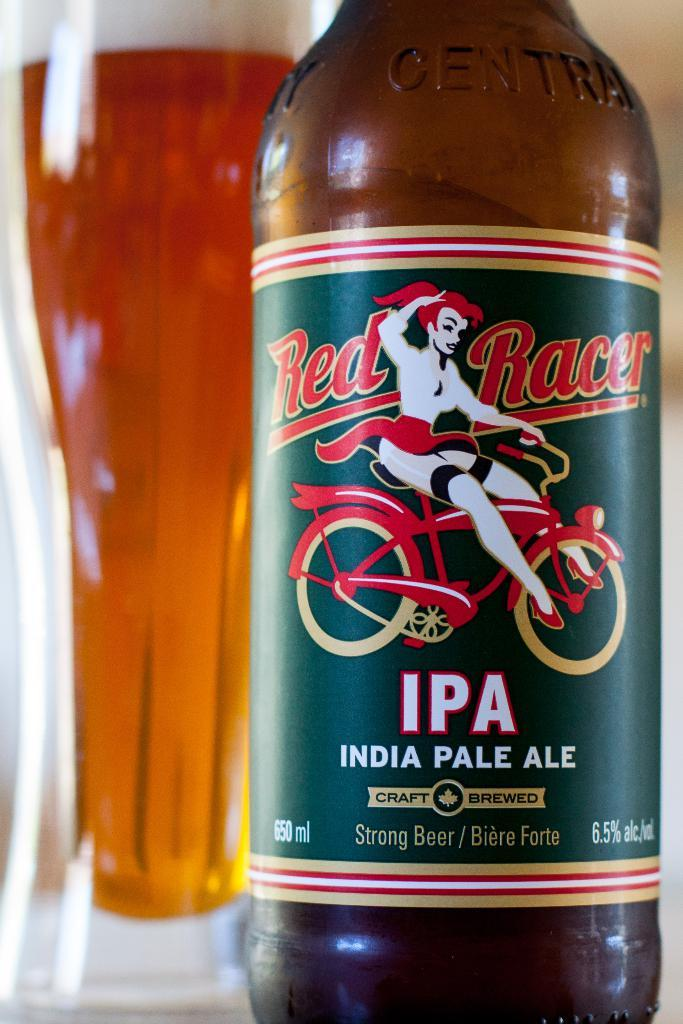What type of beverage container is present in the image? There is a beer bottle in the image. What other alcoholic beverage can be seen in the image? There is a glass of alcohol in the image. What type of chess piece is visible in the image? There is no chess piece present in the image. What type of water source can be seen in the image? There is no water source, such as a faucet, present in the image. 